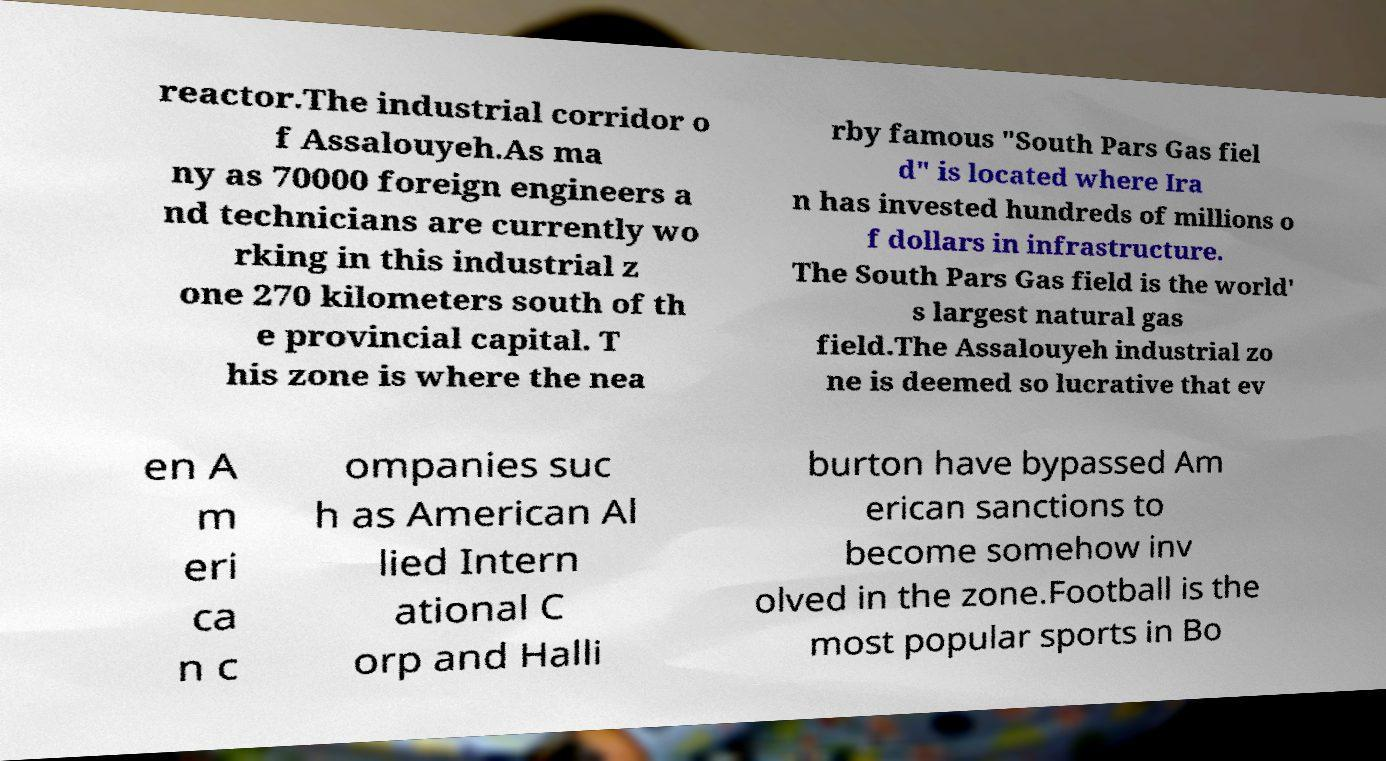I need the written content from this picture converted into text. Can you do that? reactor.The industrial corridor o f Assalouyeh.As ma ny as 70000 foreign engineers a nd technicians are currently wo rking in this industrial z one 270 kilometers south of th e provincial capital. T his zone is where the nea rby famous "South Pars Gas fiel d" is located where Ira n has invested hundreds of millions o f dollars in infrastructure. The South Pars Gas field is the world' s largest natural gas field.The Assalouyeh industrial zo ne is deemed so lucrative that ev en A m eri ca n c ompanies suc h as American Al lied Intern ational C orp and Halli burton have bypassed Am erican sanctions to become somehow inv olved in the zone.Football is the most popular sports in Bo 